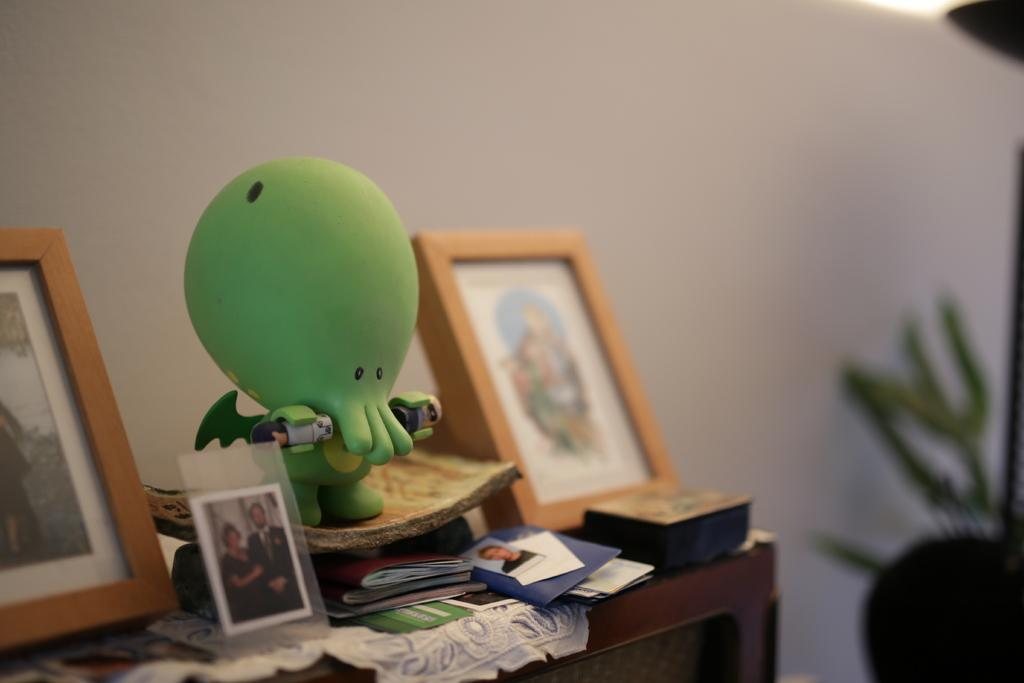What objects are on the table in the image? There are photo frames, a toy, books, photos, and cloth on the table in the image. What type of item is the toy? The toy is not specified in the image. What can be seen on the photo frames and photos? The contents of the photo frames and photos are not visible in the image. What is the condition of the background in the image? The background of the image is blurred. What type of birthday cake is being held by the beginner in the image? There is no birthday cake or beginner present in the image. How does the grip of the person holding the toy in the image compare to that of an expert? There is no person holding the toy in the image, so it is not possible to compare their grip to that of an expert. 